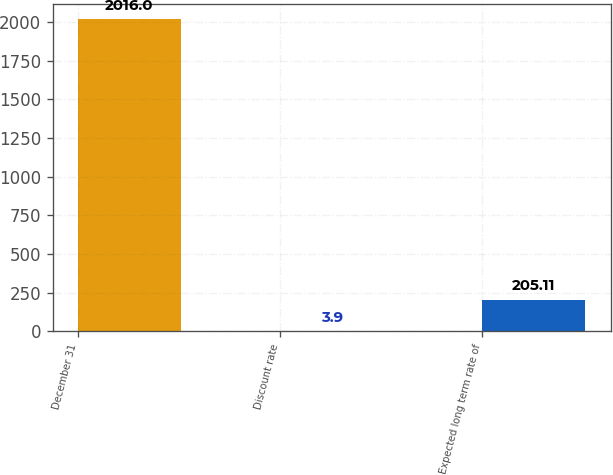Convert chart. <chart><loc_0><loc_0><loc_500><loc_500><bar_chart><fcel>December 31<fcel>Discount rate<fcel>Expected long term rate of<nl><fcel>2016<fcel>3.9<fcel>205.11<nl></chart> 